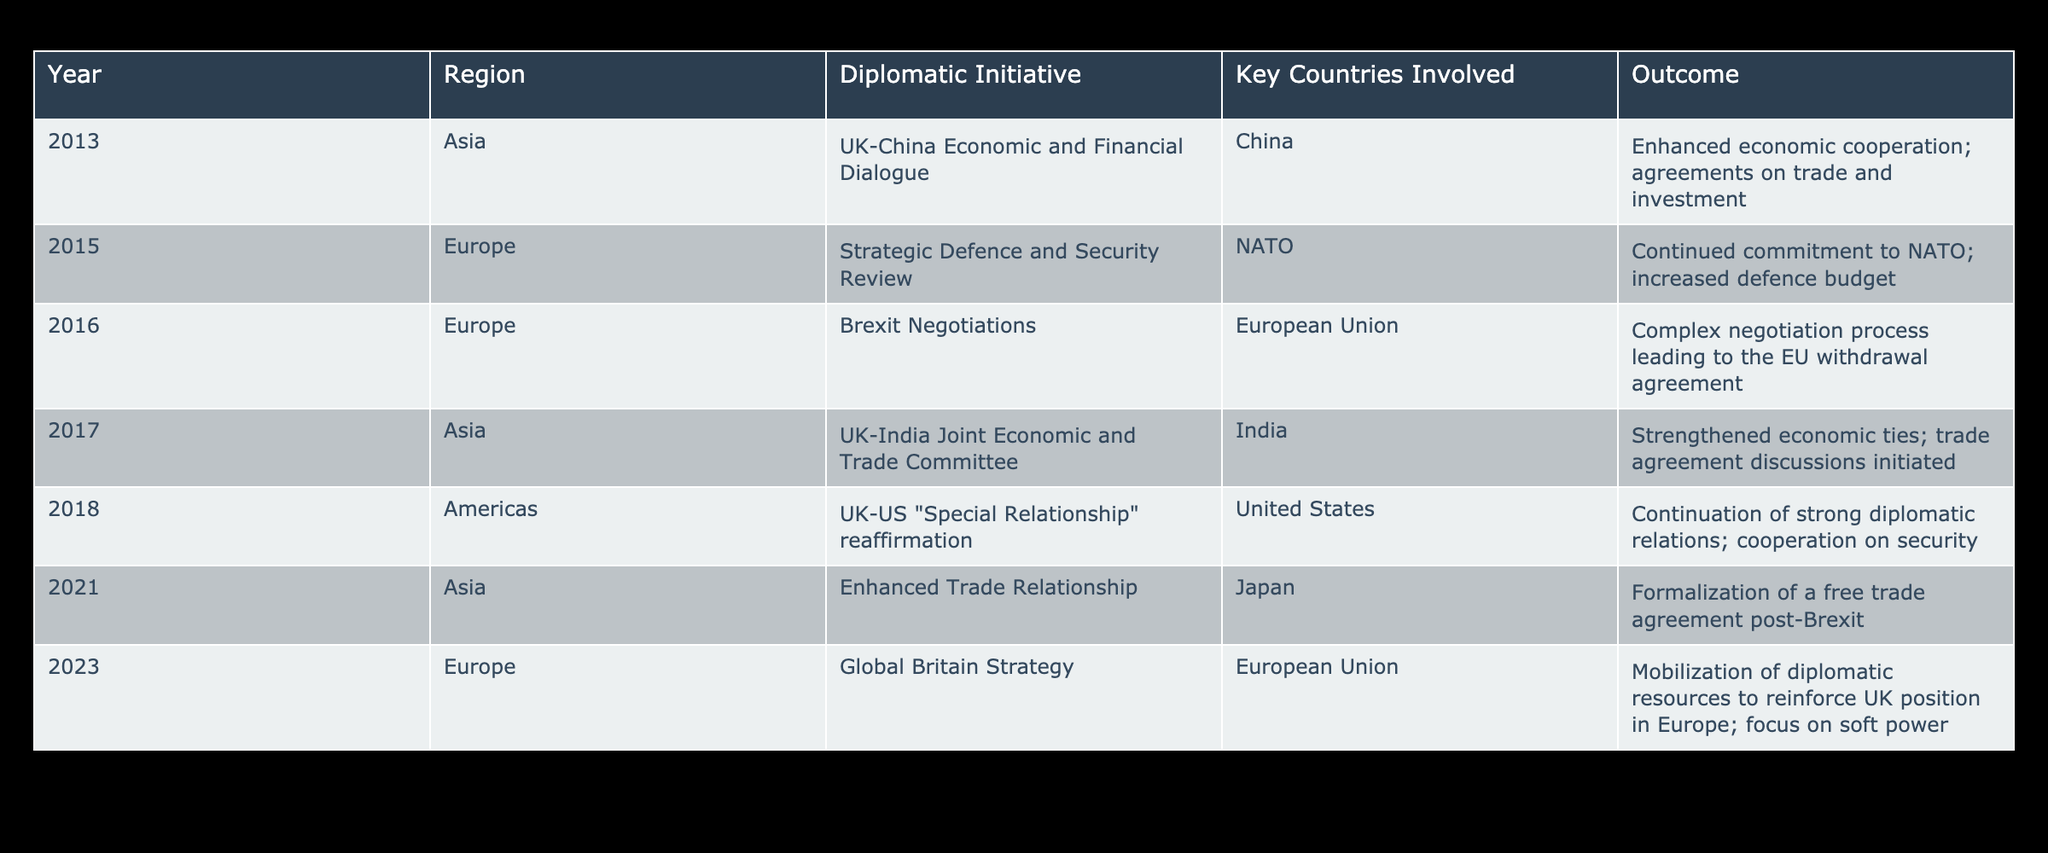What diplomatic initiative was taken in Asia in 2013? The table shows that in 2013, the UK-China Economic and Financial Dialogue was the diplomatic initiative taken in Asia, involving China.
Answer: UK-China Economic and Financial Dialogue How many diplomatic initiatives involved the European Union? By examining the table, the initiatives involving the European Union are the Brexit Negotiations in 2016 and the Global Britain Strategy in 2023. Thus, there are two initiatives.
Answer: 2 In which year was the UK-India Joint Economic and Trade Committee initiated? The table indicates that the UK-India Joint Economic and Trade Committee was initiated in 2017.
Answer: 2017 Did the UK confirm its strategic defence commitment to NATO in 2015? The outcome for the Strategic Defence and Security Review in 2015 states a continued commitment to NATO, indicating a confirmation of its strategic defense commitment.
Answer: Yes Which region saw a formalization of a free trade agreement post-Brexit in 2021? As listed in the table for the year 2021, the Enhanced Trade Relationship was the diplomatic initiative that formalized a free trade agreement, and it was for the Asia region.
Answer: Asia What is the average number of diplomatic initiatives per region listed for Asia? There are three diplomatic initiatives listed for Asia: UK-China Economic and Financial Dialogue (2013), UK-India Joint Economic and Trade Committee (2017), and Enhanced Trade Relationship (2021). The average number of initiatives per year for Asia is 3 initiatives over 3 years, making it 1 initiative per year.
Answer: 1 Was there a diplomatic initiative involving the United States, and if so, what was the outcome? The UK-US "Special Relationship" reaffirmation in 2018 involved the United States, with the table showing that it resulted in the continuation of strong diplomatic relations and cooperation on security.
Answer: Yes Which diplomatic initiative took place most recently in Europe? The most recent diplomatic initiative in Europe listed in the table is the Global Britain Strategy, which took place in 2023.
Answer: Global Britain Strategy 